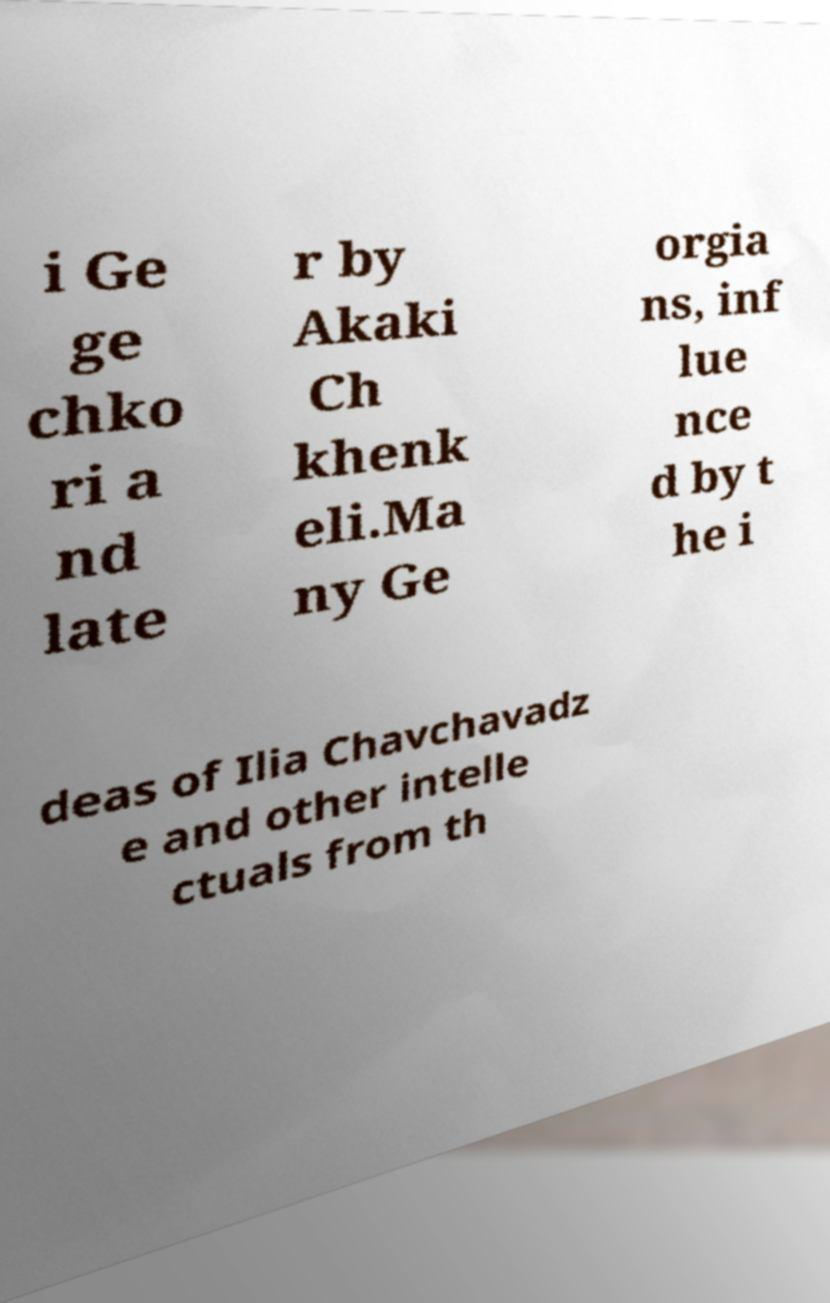There's text embedded in this image that I need extracted. Can you transcribe it verbatim? i Ge ge chko ri a nd late r by Akaki Ch khenk eli.Ma ny Ge orgia ns, inf lue nce d by t he i deas of Ilia Chavchavadz e and other intelle ctuals from th 